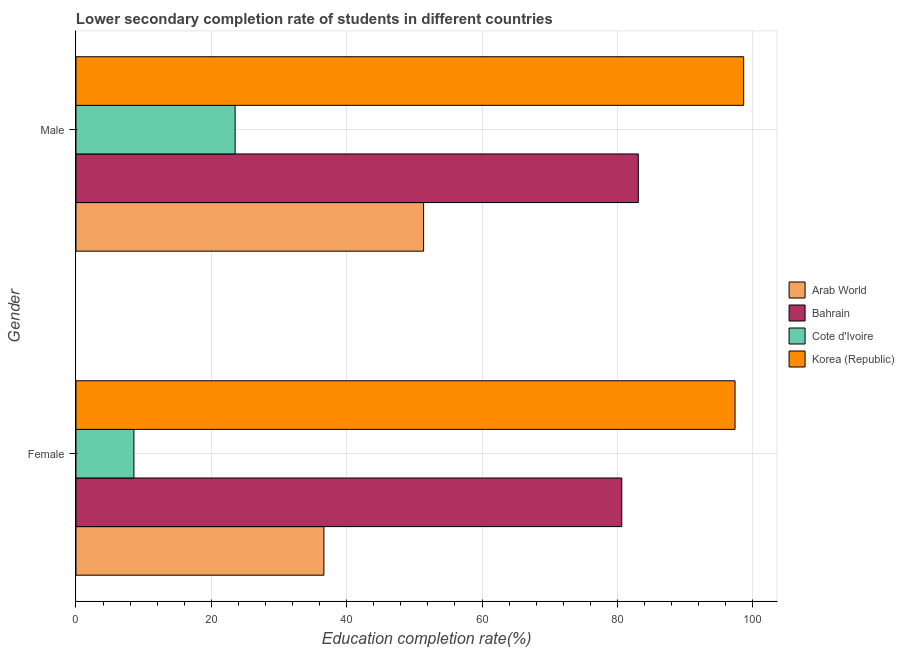How many groups of bars are there?
Your answer should be compact. 2. Are the number of bars per tick equal to the number of legend labels?
Your answer should be compact. Yes. Are the number of bars on each tick of the Y-axis equal?
Provide a succinct answer. Yes. How many bars are there on the 2nd tick from the bottom?
Offer a terse response. 4. What is the label of the 1st group of bars from the top?
Make the answer very short. Male. What is the education completion rate of female students in Bahrain?
Provide a short and direct response. 80.65. Across all countries, what is the maximum education completion rate of male students?
Offer a very short reply. 98.66. Across all countries, what is the minimum education completion rate of female students?
Provide a short and direct response. 8.56. In which country was the education completion rate of female students minimum?
Offer a terse response. Cote d'Ivoire. What is the total education completion rate of male students in the graph?
Keep it short and to the point. 256.62. What is the difference between the education completion rate of female students in Korea (Republic) and that in Bahrain?
Offer a terse response. 16.74. What is the difference between the education completion rate of male students in Bahrain and the education completion rate of female students in Arab World?
Keep it short and to the point. 46.45. What is the average education completion rate of male students per country?
Your answer should be compact. 64.15. What is the difference between the education completion rate of male students and education completion rate of female students in Arab World?
Offer a terse response. 14.73. What is the ratio of the education completion rate of male students in Bahrain to that in Arab World?
Ensure brevity in your answer.  1.62. Is the education completion rate of male students in Korea (Republic) less than that in Bahrain?
Keep it short and to the point. No. What does the 2nd bar from the top in Female represents?
Make the answer very short. Cote d'Ivoire. What does the 3rd bar from the bottom in Female represents?
Your answer should be compact. Cote d'Ivoire. How many bars are there?
Provide a short and direct response. 8. How many countries are there in the graph?
Provide a short and direct response. 4. What is the difference between two consecutive major ticks on the X-axis?
Provide a short and direct response. 20. Are the values on the major ticks of X-axis written in scientific E-notation?
Provide a short and direct response. No. Does the graph contain any zero values?
Provide a succinct answer. No. Where does the legend appear in the graph?
Your answer should be very brief. Center right. How many legend labels are there?
Your answer should be very brief. 4. How are the legend labels stacked?
Your answer should be compact. Vertical. What is the title of the graph?
Make the answer very short. Lower secondary completion rate of students in different countries. Does "Tonga" appear as one of the legend labels in the graph?
Ensure brevity in your answer.  No. What is the label or title of the X-axis?
Make the answer very short. Education completion rate(%). What is the label or title of the Y-axis?
Your answer should be compact. Gender. What is the Education completion rate(%) of Arab World in Female?
Provide a succinct answer. 36.63. What is the Education completion rate(%) in Bahrain in Female?
Ensure brevity in your answer.  80.65. What is the Education completion rate(%) in Cote d'Ivoire in Female?
Your response must be concise. 8.56. What is the Education completion rate(%) in Korea (Republic) in Female?
Give a very brief answer. 97.38. What is the Education completion rate(%) of Arab World in Male?
Provide a short and direct response. 51.36. What is the Education completion rate(%) in Bahrain in Male?
Offer a terse response. 83.08. What is the Education completion rate(%) in Cote d'Ivoire in Male?
Your answer should be compact. 23.51. What is the Education completion rate(%) of Korea (Republic) in Male?
Your answer should be very brief. 98.66. Across all Gender, what is the maximum Education completion rate(%) in Arab World?
Offer a very short reply. 51.36. Across all Gender, what is the maximum Education completion rate(%) of Bahrain?
Your answer should be very brief. 83.08. Across all Gender, what is the maximum Education completion rate(%) of Cote d'Ivoire?
Your response must be concise. 23.51. Across all Gender, what is the maximum Education completion rate(%) in Korea (Republic)?
Offer a very short reply. 98.66. Across all Gender, what is the minimum Education completion rate(%) of Arab World?
Give a very brief answer. 36.63. Across all Gender, what is the minimum Education completion rate(%) in Bahrain?
Your response must be concise. 80.65. Across all Gender, what is the minimum Education completion rate(%) of Cote d'Ivoire?
Provide a succinct answer. 8.56. Across all Gender, what is the minimum Education completion rate(%) of Korea (Republic)?
Ensure brevity in your answer.  97.38. What is the total Education completion rate(%) in Arab World in the graph?
Your answer should be very brief. 88. What is the total Education completion rate(%) of Bahrain in the graph?
Keep it short and to the point. 163.73. What is the total Education completion rate(%) in Cote d'Ivoire in the graph?
Provide a succinct answer. 32.07. What is the total Education completion rate(%) in Korea (Republic) in the graph?
Ensure brevity in your answer.  196.04. What is the difference between the Education completion rate(%) of Arab World in Female and that in Male?
Your answer should be very brief. -14.73. What is the difference between the Education completion rate(%) in Bahrain in Female and that in Male?
Your answer should be very brief. -2.44. What is the difference between the Education completion rate(%) in Cote d'Ivoire in Female and that in Male?
Offer a terse response. -14.96. What is the difference between the Education completion rate(%) in Korea (Republic) in Female and that in Male?
Provide a succinct answer. -1.28. What is the difference between the Education completion rate(%) of Arab World in Female and the Education completion rate(%) of Bahrain in Male?
Offer a terse response. -46.45. What is the difference between the Education completion rate(%) of Arab World in Female and the Education completion rate(%) of Cote d'Ivoire in Male?
Provide a short and direct response. 13.12. What is the difference between the Education completion rate(%) of Arab World in Female and the Education completion rate(%) of Korea (Republic) in Male?
Ensure brevity in your answer.  -62.02. What is the difference between the Education completion rate(%) in Bahrain in Female and the Education completion rate(%) in Cote d'Ivoire in Male?
Provide a succinct answer. 57.13. What is the difference between the Education completion rate(%) of Bahrain in Female and the Education completion rate(%) of Korea (Republic) in Male?
Your answer should be very brief. -18.01. What is the difference between the Education completion rate(%) of Cote d'Ivoire in Female and the Education completion rate(%) of Korea (Republic) in Male?
Give a very brief answer. -90.1. What is the average Education completion rate(%) in Arab World per Gender?
Keep it short and to the point. 44. What is the average Education completion rate(%) in Bahrain per Gender?
Provide a short and direct response. 81.86. What is the average Education completion rate(%) in Cote d'Ivoire per Gender?
Your answer should be very brief. 16.04. What is the average Education completion rate(%) of Korea (Republic) per Gender?
Give a very brief answer. 98.02. What is the difference between the Education completion rate(%) of Arab World and Education completion rate(%) of Bahrain in Female?
Provide a succinct answer. -44.01. What is the difference between the Education completion rate(%) of Arab World and Education completion rate(%) of Cote d'Ivoire in Female?
Provide a short and direct response. 28.07. What is the difference between the Education completion rate(%) of Arab World and Education completion rate(%) of Korea (Republic) in Female?
Your response must be concise. -60.75. What is the difference between the Education completion rate(%) of Bahrain and Education completion rate(%) of Cote d'Ivoire in Female?
Offer a terse response. 72.09. What is the difference between the Education completion rate(%) in Bahrain and Education completion rate(%) in Korea (Republic) in Female?
Your answer should be compact. -16.74. What is the difference between the Education completion rate(%) of Cote d'Ivoire and Education completion rate(%) of Korea (Republic) in Female?
Offer a terse response. -88.82. What is the difference between the Education completion rate(%) in Arab World and Education completion rate(%) in Bahrain in Male?
Ensure brevity in your answer.  -31.72. What is the difference between the Education completion rate(%) in Arab World and Education completion rate(%) in Cote d'Ivoire in Male?
Ensure brevity in your answer.  27.85. What is the difference between the Education completion rate(%) of Arab World and Education completion rate(%) of Korea (Republic) in Male?
Your response must be concise. -47.29. What is the difference between the Education completion rate(%) of Bahrain and Education completion rate(%) of Cote d'Ivoire in Male?
Your answer should be very brief. 59.57. What is the difference between the Education completion rate(%) of Bahrain and Education completion rate(%) of Korea (Republic) in Male?
Offer a terse response. -15.57. What is the difference between the Education completion rate(%) of Cote d'Ivoire and Education completion rate(%) of Korea (Republic) in Male?
Provide a succinct answer. -75.14. What is the ratio of the Education completion rate(%) of Arab World in Female to that in Male?
Your response must be concise. 0.71. What is the ratio of the Education completion rate(%) of Bahrain in Female to that in Male?
Your answer should be compact. 0.97. What is the ratio of the Education completion rate(%) in Cote d'Ivoire in Female to that in Male?
Offer a terse response. 0.36. What is the ratio of the Education completion rate(%) in Korea (Republic) in Female to that in Male?
Ensure brevity in your answer.  0.99. What is the difference between the highest and the second highest Education completion rate(%) of Arab World?
Your answer should be compact. 14.73. What is the difference between the highest and the second highest Education completion rate(%) of Bahrain?
Provide a succinct answer. 2.44. What is the difference between the highest and the second highest Education completion rate(%) of Cote d'Ivoire?
Give a very brief answer. 14.96. What is the difference between the highest and the second highest Education completion rate(%) in Korea (Republic)?
Provide a short and direct response. 1.28. What is the difference between the highest and the lowest Education completion rate(%) in Arab World?
Your response must be concise. 14.73. What is the difference between the highest and the lowest Education completion rate(%) in Bahrain?
Your answer should be compact. 2.44. What is the difference between the highest and the lowest Education completion rate(%) in Cote d'Ivoire?
Make the answer very short. 14.96. What is the difference between the highest and the lowest Education completion rate(%) in Korea (Republic)?
Ensure brevity in your answer.  1.28. 